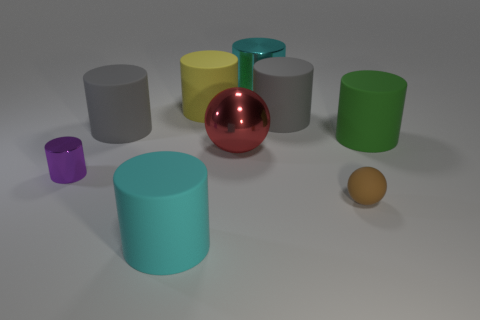Is the red sphere the same size as the brown ball?
Ensure brevity in your answer.  No. How many objects are big cylinders that are in front of the tiny sphere or small yellow matte spheres?
Provide a short and direct response. 1. There is a gray cylinder that is on the right side of the big thing that is behind the yellow cylinder; what is its material?
Your answer should be compact. Rubber. Are there any other big things of the same shape as the brown rubber object?
Give a very brief answer. Yes. There is a brown thing; does it have the same size as the cyan cylinder behind the large green rubber cylinder?
Make the answer very short. No. How many things are big cyan cylinders that are right of the red metallic thing or cyan shiny objects behind the big red shiny thing?
Provide a short and direct response. 1. Is the number of gray matte cylinders behind the small brown thing greater than the number of small cyan shiny cylinders?
Give a very brief answer. Yes. How many purple metallic cylinders are the same size as the cyan rubber thing?
Offer a very short reply. 0. Is the size of the cyan object in front of the matte sphere the same as the metal cylinder on the left side of the cyan matte thing?
Keep it short and to the point. No. How big is the metal cylinder in front of the yellow cylinder?
Your response must be concise. Small. 